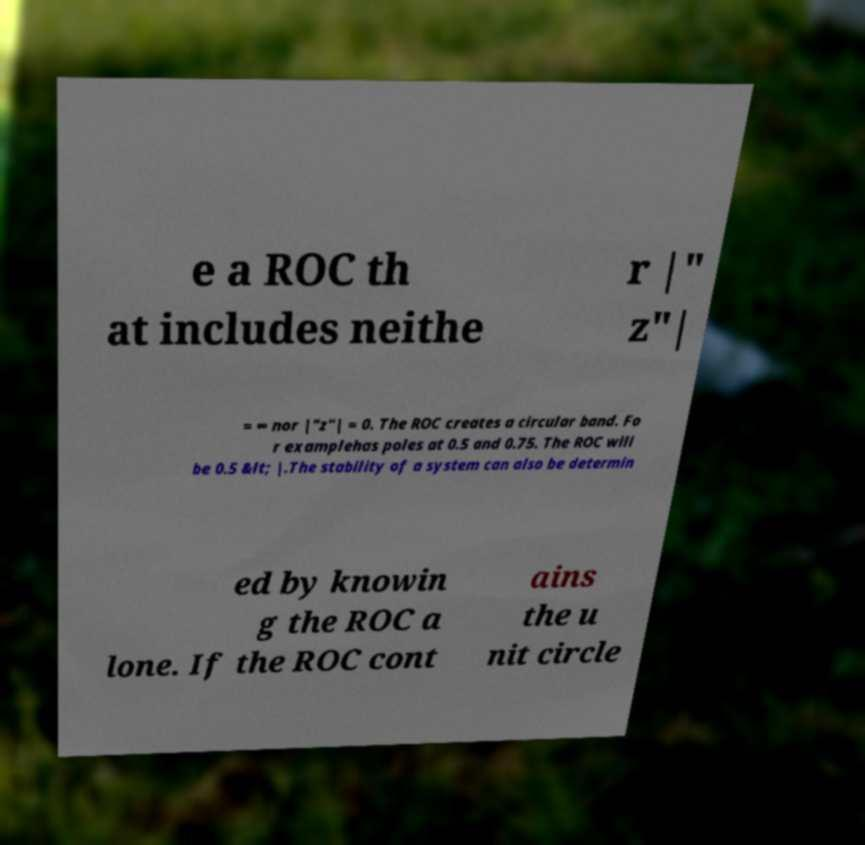Could you extract and type out the text from this image? e a ROC th at includes neithe r |" z"| = ∞ nor |"z"| = 0. The ROC creates a circular band. Fo r examplehas poles at 0.5 and 0.75. The ROC will be 0.5 &lt; |.The stability of a system can also be determin ed by knowin g the ROC a lone. If the ROC cont ains the u nit circle 